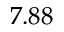<formula> <loc_0><loc_0><loc_500><loc_500>7 . 8 8</formula> 